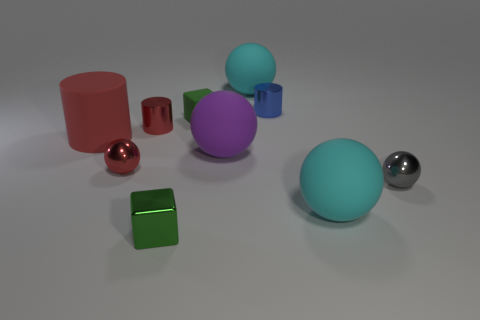Are there any patterns or symmetries to be observed? While there are no explicit patterns or symmetries with respect to arrangement, there is a symmetry in terms of the number of spheres and cylinders – there are three spheres and two cylinders. The colors are varied and do not follow a specific pattern, and the arrangement seems random with differing orientations and positions on the flat surface. 